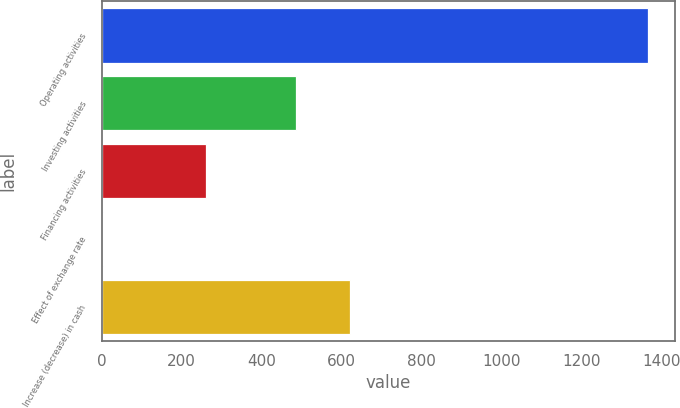Convert chart to OTSL. <chart><loc_0><loc_0><loc_500><loc_500><bar_chart><fcel>Operating activities<fcel>Investing activities<fcel>Financing activities<fcel>Effect of exchange rate<fcel>Increase (decrease) in cash<nl><fcel>1366<fcel>485<fcel>262<fcel>3<fcel>621.3<nl></chart> 